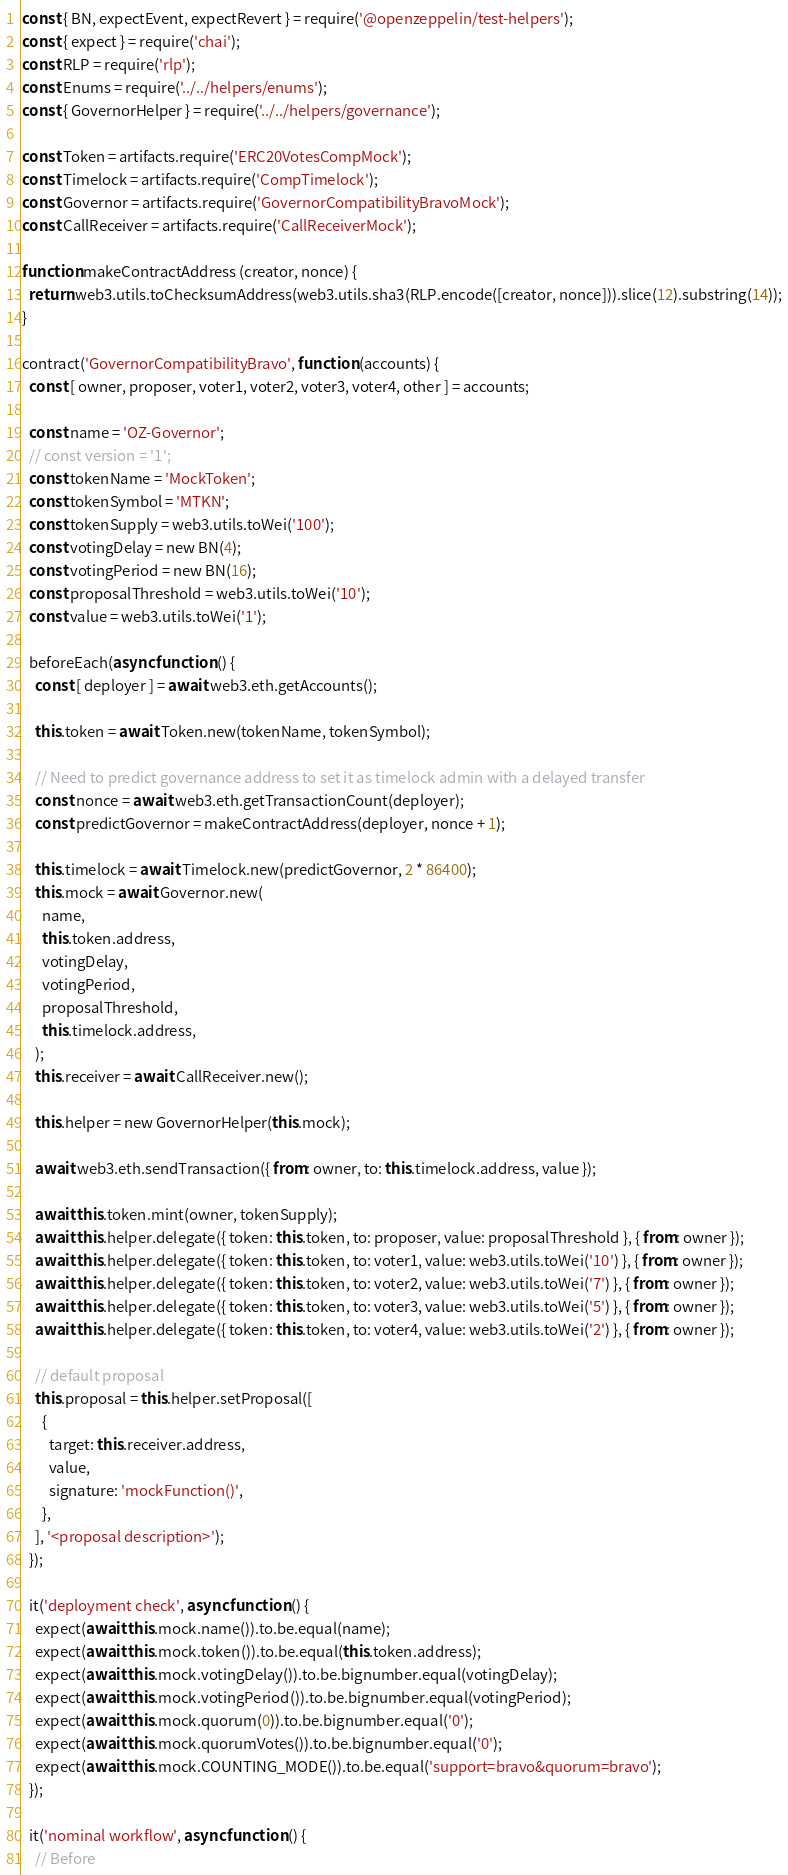Convert code to text. <code><loc_0><loc_0><loc_500><loc_500><_JavaScript_>const { BN, expectEvent, expectRevert } = require('@openzeppelin/test-helpers');
const { expect } = require('chai');
const RLP = require('rlp');
const Enums = require('../../helpers/enums');
const { GovernorHelper } = require('../../helpers/governance');

const Token = artifacts.require('ERC20VotesCompMock');
const Timelock = artifacts.require('CompTimelock');
const Governor = artifacts.require('GovernorCompatibilityBravoMock');
const CallReceiver = artifacts.require('CallReceiverMock');

function makeContractAddress (creator, nonce) {
  return web3.utils.toChecksumAddress(web3.utils.sha3(RLP.encode([creator, nonce])).slice(12).substring(14));
}

contract('GovernorCompatibilityBravo', function (accounts) {
  const [ owner, proposer, voter1, voter2, voter3, voter4, other ] = accounts;

  const name = 'OZ-Governor';
  // const version = '1';
  const tokenName = 'MockToken';
  const tokenSymbol = 'MTKN';
  const tokenSupply = web3.utils.toWei('100');
  const votingDelay = new BN(4);
  const votingPeriod = new BN(16);
  const proposalThreshold = web3.utils.toWei('10');
  const value = web3.utils.toWei('1');

  beforeEach(async function () {
    const [ deployer ] = await web3.eth.getAccounts();

    this.token = await Token.new(tokenName, tokenSymbol);

    // Need to predict governance address to set it as timelock admin with a delayed transfer
    const nonce = await web3.eth.getTransactionCount(deployer);
    const predictGovernor = makeContractAddress(deployer, nonce + 1);

    this.timelock = await Timelock.new(predictGovernor, 2 * 86400);
    this.mock = await Governor.new(
      name,
      this.token.address,
      votingDelay,
      votingPeriod,
      proposalThreshold,
      this.timelock.address,
    );
    this.receiver = await CallReceiver.new();

    this.helper = new GovernorHelper(this.mock);

    await web3.eth.sendTransaction({ from: owner, to: this.timelock.address, value });

    await this.token.mint(owner, tokenSupply);
    await this.helper.delegate({ token: this.token, to: proposer, value: proposalThreshold }, { from: owner });
    await this.helper.delegate({ token: this.token, to: voter1, value: web3.utils.toWei('10') }, { from: owner });
    await this.helper.delegate({ token: this.token, to: voter2, value: web3.utils.toWei('7') }, { from: owner });
    await this.helper.delegate({ token: this.token, to: voter3, value: web3.utils.toWei('5') }, { from: owner });
    await this.helper.delegate({ token: this.token, to: voter4, value: web3.utils.toWei('2') }, { from: owner });

    // default proposal
    this.proposal = this.helper.setProposal([
      {
        target: this.receiver.address,
        value,
        signature: 'mockFunction()',
      },
    ], '<proposal description>');
  });

  it('deployment check', async function () {
    expect(await this.mock.name()).to.be.equal(name);
    expect(await this.mock.token()).to.be.equal(this.token.address);
    expect(await this.mock.votingDelay()).to.be.bignumber.equal(votingDelay);
    expect(await this.mock.votingPeriod()).to.be.bignumber.equal(votingPeriod);
    expect(await this.mock.quorum(0)).to.be.bignumber.equal('0');
    expect(await this.mock.quorumVotes()).to.be.bignumber.equal('0');
    expect(await this.mock.COUNTING_MODE()).to.be.equal('support=bravo&quorum=bravo');
  });

  it('nominal workflow', async function () {
    // Before</code> 